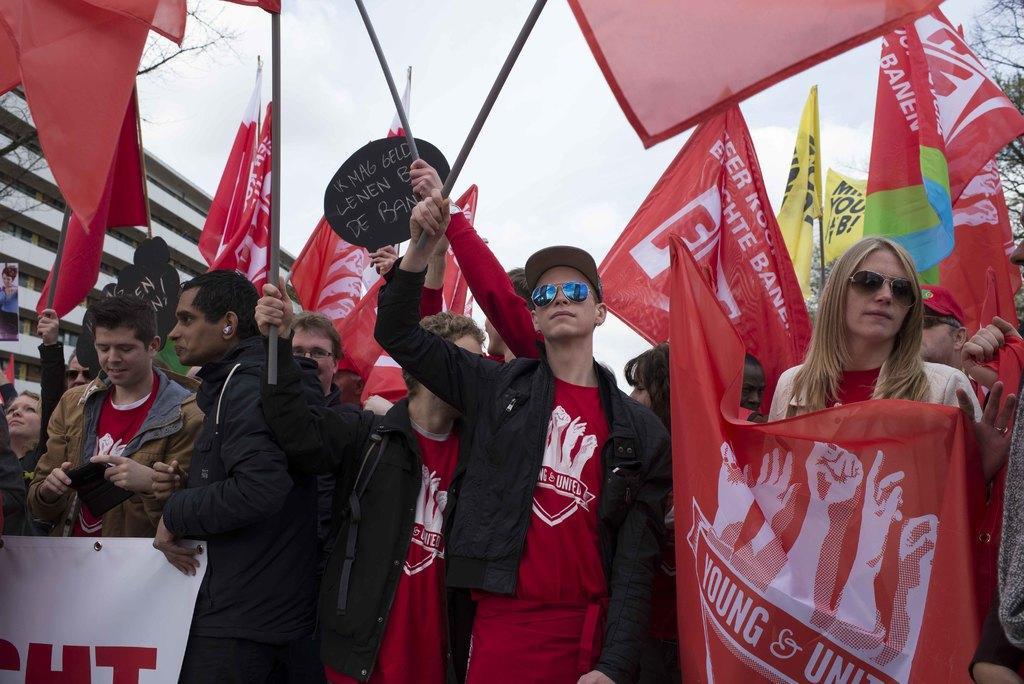How would you summarize this image in a sentence or two? There is a crowd. Some people are wearing goggles and holding flags and banners. In the background there is sky, building and trees. 